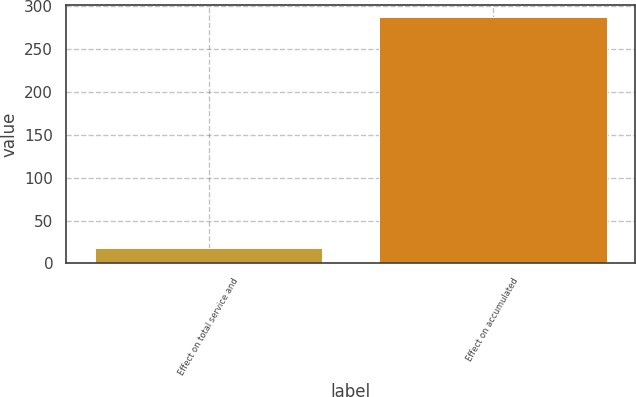Convert chart. <chart><loc_0><loc_0><loc_500><loc_500><bar_chart><fcel>Effect on total service and<fcel>Effect on accumulated<nl><fcel>18<fcel>287<nl></chart> 